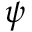Convert formula to latex. <formula><loc_0><loc_0><loc_500><loc_500>\psi</formula> 